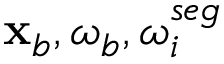<formula> <loc_0><loc_0><loc_500><loc_500>{ x } _ { b } , { \omega _ { b } } , { \omega _ { i } ^ { s e g } }</formula> 